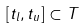<formula> <loc_0><loc_0><loc_500><loc_500>[ t _ { l } , t _ { u } ] \subset T</formula> 